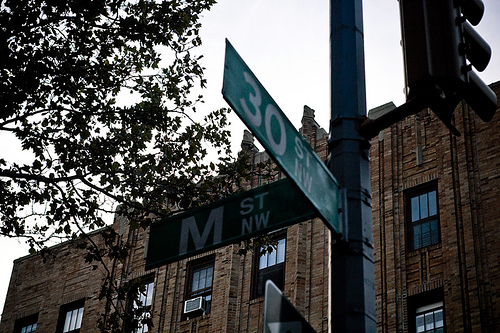Read and extract the text from this image. 30 M ST NW NW ST 